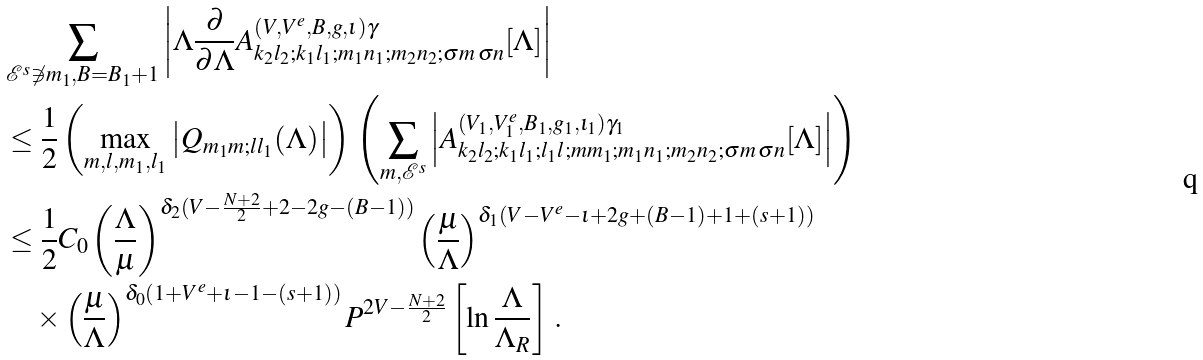Convert formula to latex. <formula><loc_0><loc_0><loc_500><loc_500>& \sum _ { \mathcal { E } ^ { s } \not \ni m _ { 1 } , B = B _ { 1 } + 1 } \left | \Lambda \frac { \partial } { \partial \Lambda } A ^ { ( V , V ^ { e } , B , g , \iota ) \gamma } _ { k _ { 2 } l _ { 2 } ; k _ { 1 } l _ { 1 } ; m _ { 1 } n _ { 1 } ; m _ { 2 } n _ { 2 } ; \sigma m \, \sigma n } [ \Lambda ] \right | \\ & \leq \frac { 1 } { 2 } \left ( \max _ { m , l , m _ { 1 } , l _ { 1 } } \left | Q _ { m _ { 1 } m ; l l _ { 1 } } ( \Lambda ) \right | \right ) \, \left ( \sum _ { m , \mathcal { E } ^ { s } } \left | A ^ { ( V _ { 1 } , V ^ { e } _ { 1 } , B _ { 1 } , g _ { 1 } , \iota _ { 1 } ) \gamma _ { 1 } } _ { k _ { 2 } l _ { 2 } ; k _ { 1 } l _ { 1 } ; l _ { 1 } l ; m m _ { 1 } ; m _ { 1 } n _ { 1 } ; m _ { 2 } n _ { 2 } ; \sigma m \, \sigma n } [ \Lambda ] \right | \right ) \\ & \leq \frac { 1 } { 2 } C _ { 0 } \left ( \frac { \Lambda } { \mu } \right ) ^ { \delta _ { 2 } ( V - \frac { N + 2 } { 2 } + 2 - 2 g - ( B - 1 ) ) } \left ( \frac { \mu } { \Lambda } \right ) ^ { \delta _ { 1 } ( V - V ^ { e } - \iota + 2 g + ( B - 1 ) + 1 + ( s + 1 ) ) } \\ & \quad \times \left ( \frac { \mu } { \Lambda } \right ) ^ { \delta _ { 0 } ( 1 + V ^ { e } + \iota - 1 - ( s + 1 ) ) } P ^ { 2 V - \frac { N + 2 } { 2 } } \left [ \ln \frac { \Lambda } { \Lambda _ { R } } \right ] \, .</formula> 